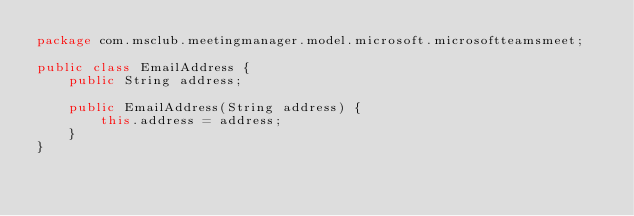Convert code to text. <code><loc_0><loc_0><loc_500><loc_500><_Java_>package com.msclub.meetingmanager.model.microsoft.microsoftteamsmeet;

public class EmailAddress {
    public String address;

    public EmailAddress(String address) {
        this.address = address;
    }
}
</code> 